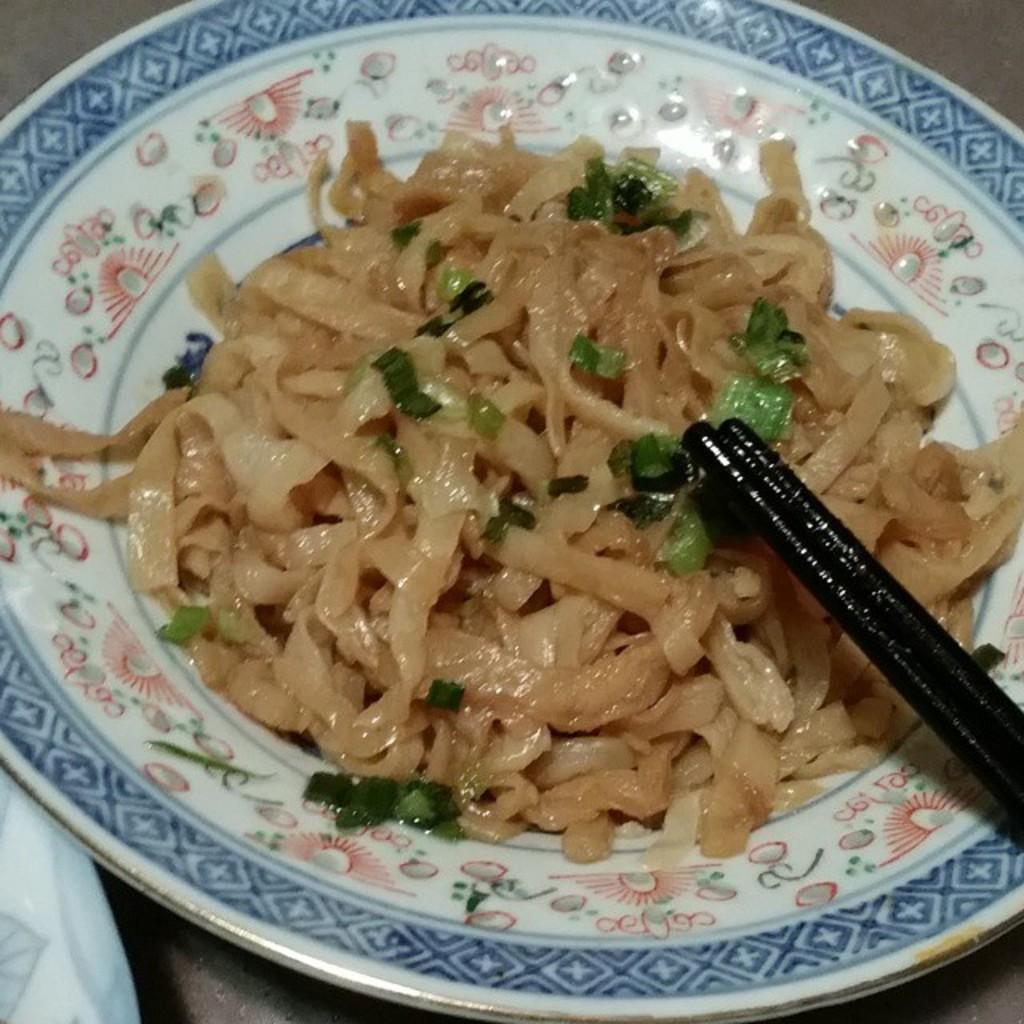What is on the plate that is visible in the image? There is a plate with food items in the image. What utensil is present in the image? Chopsticks are visible in the image. How many beans are on the plate in the image? There is no mention of beans in the image; it only shows a plate with food items and chopsticks. 